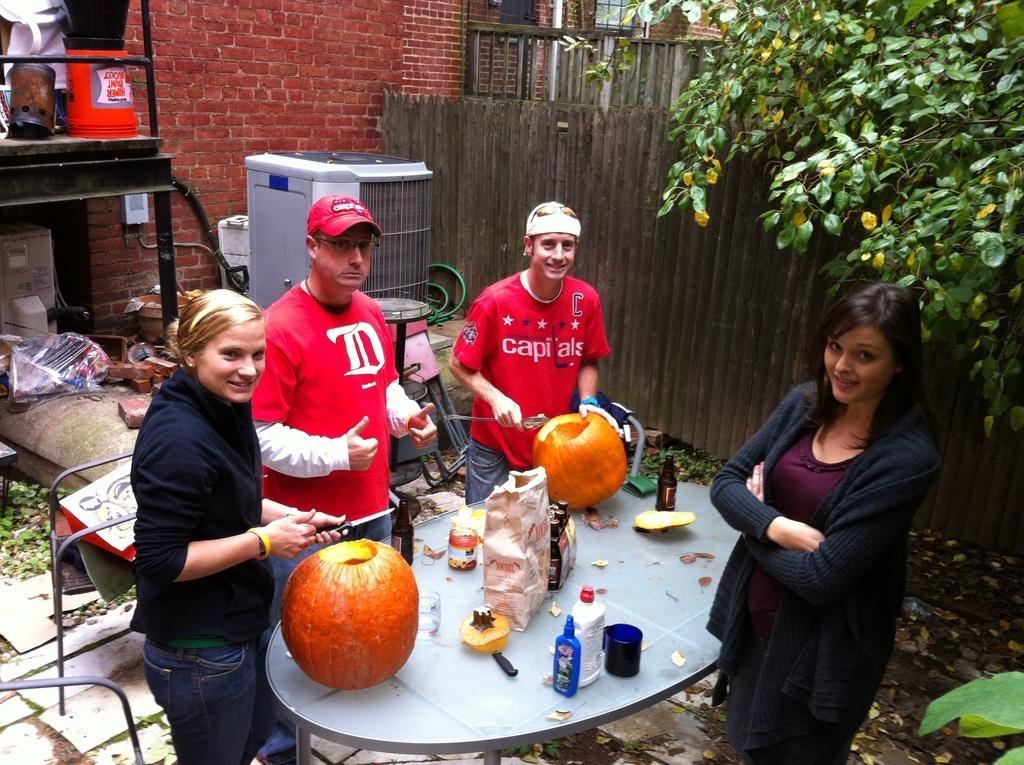Please provide a concise description of this image. There are people standing, pumpkins, bottles and other objects on the table in the foreground area of the image, it seems like a rack, other objects and a wall, boundary and the greenery in the background. 